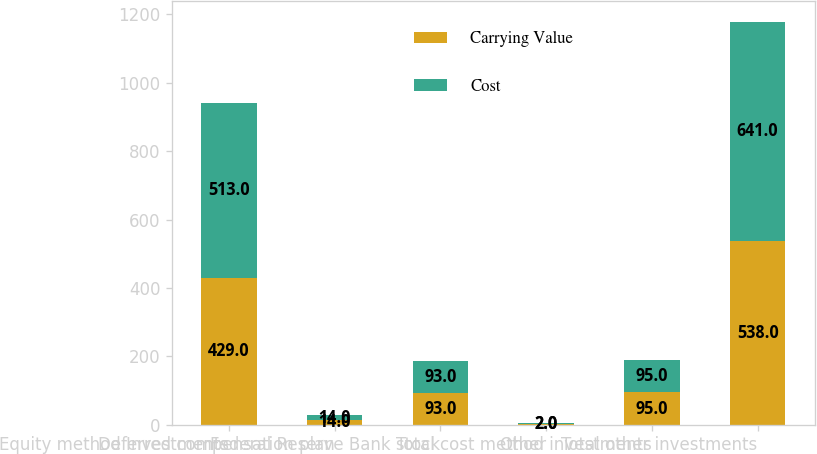<chart> <loc_0><loc_0><loc_500><loc_500><stacked_bar_chart><ecel><fcel>Equity method Investments<fcel>Deferred compensation plan<fcel>Federal Reserve Bank stock<fcel>Other<fcel>Total cost method investments<fcel>Total other investments<nl><fcel>Carrying Value<fcel>429<fcel>14<fcel>93<fcel>2<fcel>95<fcel>538<nl><fcel>Cost<fcel>513<fcel>14<fcel>93<fcel>2<fcel>95<fcel>641<nl></chart> 